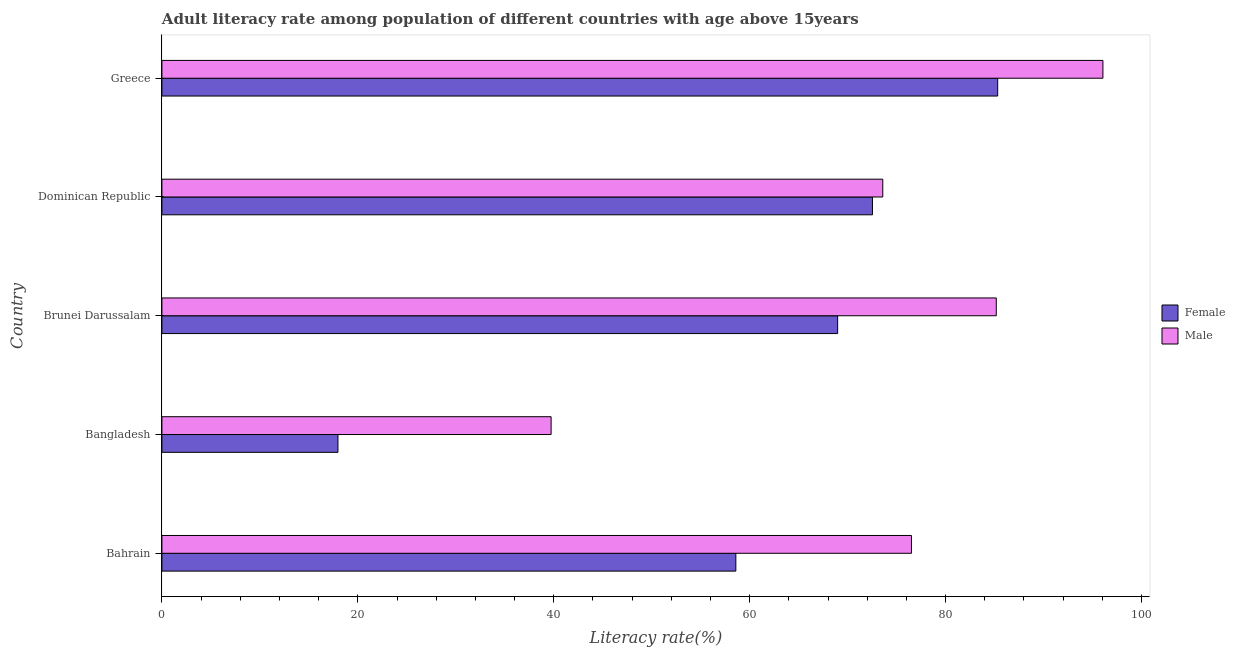How many different coloured bars are there?
Make the answer very short. 2. How many groups of bars are there?
Keep it short and to the point. 5. Are the number of bars per tick equal to the number of legend labels?
Your answer should be compact. Yes. How many bars are there on the 2nd tick from the top?
Offer a very short reply. 2. What is the label of the 5th group of bars from the top?
Offer a terse response. Bahrain. In how many cases, is the number of bars for a given country not equal to the number of legend labels?
Make the answer very short. 0. What is the female adult literacy rate in Dominican Republic?
Make the answer very short. 72.54. Across all countries, what is the maximum male adult literacy rate?
Offer a terse response. 96.06. Across all countries, what is the minimum female adult literacy rate?
Give a very brief answer. 17.97. In which country was the male adult literacy rate maximum?
Your response must be concise. Greece. In which country was the male adult literacy rate minimum?
Your response must be concise. Bangladesh. What is the total female adult literacy rate in the graph?
Keep it short and to the point. 303.4. What is the difference between the male adult literacy rate in Bahrain and that in Dominican Republic?
Keep it short and to the point. 2.93. What is the difference between the male adult literacy rate in Brunei Darussalam and the female adult literacy rate in Greece?
Your response must be concise. -0.14. What is the average female adult literacy rate per country?
Offer a terse response. 60.68. What is the difference between the female adult literacy rate and male adult literacy rate in Bangladesh?
Offer a terse response. -21.76. In how many countries, is the female adult literacy rate greater than 24 %?
Your response must be concise. 4. What is the ratio of the male adult literacy rate in Bahrain to that in Greece?
Keep it short and to the point. 0.8. Is the female adult literacy rate in Brunei Darussalam less than that in Greece?
Make the answer very short. Yes. Is the difference between the female adult literacy rate in Bangladesh and Brunei Darussalam greater than the difference between the male adult literacy rate in Bangladesh and Brunei Darussalam?
Keep it short and to the point. No. What is the difference between the highest and the second highest female adult literacy rate?
Give a very brief answer. 12.78. What is the difference between the highest and the lowest female adult literacy rate?
Your answer should be compact. 67.35. What does the 2nd bar from the top in Dominican Republic represents?
Provide a short and direct response. Female. What does the 1st bar from the bottom in Bahrain represents?
Give a very brief answer. Female. How many bars are there?
Provide a succinct answer. 10. Are all the bars in the graph horizontal?
Provide a short and direct response. Yes. How many countries are there in the graph?
Ensure brevity in your answer.  5. Where does the legend appear in the graph?
Your answer should be compact. Center right. How many legend labels are there?
Ensure brevity in your answer.  2. What is the title of the graph?
Your answer should be compact. Adult literacy rate among population of different countries with age above 15years. Does "Female labourers" appear as one of the legend labels in the graph?
Offer a terse response. No. What is the label or title of the X-axis?
Offer a very short reply. Literacy rate(%). What is the Literacy rate(%) of Female in Bahrain?
Keep it short and to the point. 58.59. What is the Literacy rate(%) of Male in Bahrain?
Offer a very short reply. 76.52. What is the Literacy rate(%) of Female in Bangladesh?
Your response must be concise. 17.97. What is the Literacy rate(%) in Male in Bangladesh?
Your response must be concise. 39.73. What is the Literacy rate(%) of Female in Brunei Darussalam?
Make the answer very short. 68.98. What is the Literacy rate(%) of Male in Brunei Darussalam?
Make the answer very short. 85.18. What is the Literacy rate(%) in Female in Dominican Republic?
Ensure brevity in your answer.  72.54. What is the Literacy rate(%) in Male in Dominican Republic?
Keep it short and to the point. 73.59. What is the Literacy rate(%) of Female in Greece?
Give a very brief answer. 85.32. What is the Literacy rate(%) in Male in Greece?
Provide a short and direct response. 96.06. Across all countries, what is the maximum Literacy rate(%) of Female?
Offer a terse response. 85.32. Across all countries, what is the maximum Literacy rate(%) of Male?
Make the answer very short. 96.06. Across all countries, what is the minimum Literacy rate(%) of Female?
Give a very brief answer. 17.97. Across all countries, what is the minimum Literacy rate(%) in Male?
Provide a short and direct response. 39.73. What is the total Literacy rate(%) in Female in the graph?
Ensure brevity in your answer.  303.4. What is the total Literacy rate(%) of Male in the graph?
Make the answer very short. 371.08. What is the difference between the Literacy rate(%) in Female in Bahrain and that in Bangladesh?
Your answer should be very brief. 40.62. What is the difference between the Literacy rate(%) of Male in Bahrain and that in Bangladesh?
Provide a succinct answer. 36.79. What is the difference between the Literacy rate(%) in Female in Bahrain and that in Brunei Darussalam?
Keep it short and to the point. -10.39. What is the difference between the Literacy rate(%) of Male in Bahrain and that in Brunei Darussalam?
Your answer should be very brief. -8.66. What is the difference between the Literacy rate(%) in Female in Bahrain and that in Dominican Republic?
Provide a succinct answer. -13.95. What is the difference between the Literacy rate(%) in Male in Bahrain and that in Dominican Republic?
Keep it short and to the point. 2.93. What is the difference between the Literacy rate(%) of Female in Bahrain and that in Greece?
Provide a succinct answer. -26.73. What is the difference between the Literacy rate(%) of Male in Bahrain and that in Greece?
Give a very brief answer. -19.55. What is the difference between the Literacy rate(%) of Female in Bangladesh and that in Brunei Darussalam?
Keep it short and to the point. -51.01. What is the difference between the Literacy rate(%) in Male in Bangladesh and that in Brunei Darussalam?
Make the answer very short. -45.45. What is the difference between the Literacy rate(%) in Female in Bangladesh and that in Dominican Republic?
Provide a short and direct response. -54.56. What is the difference between the Literacy rate(%) of Male in Bangladesh and that in Dominican Republic?
Your response must be concise. -33.86. What is the difference between the Literacy rate(%) of Female in Bangladesh and that in Greece?
Offer a very short reply. -67.35. What is the difference between the Literacy rate(%) in Male in Bangladesh and that in Greece?
Provide a succinct answer. -56.33. What is the difference between the Literacy rate(%) in Female in Brunei Darussalam and that in Dominican Republic?
Provide a succinct answer. -3.55. What is the difference between the Literacy rate(%) in Male in Brunei Darussalam and that in Dominican Republic?
Your answer should be compact. 11.59. What is the difference between the Literacy rate(%) in Female in Brunei Darussalam and that in Greece?
Ensure brevity in your answer.  -16.34. What is the difference between the Literacy rate(%) of Male in Brunei Darussalam and that in Greece?
Offer a very short reply. -10.89. What is the difference between the Literacy rate(%) of Female in Dominican Republic and that in Greece?
Offer a terse response. -12.78. What is the difference between the Literacy rate(%) of Male in Dominican Republic and that in Greece?
Ensure brevity in your answer.  -22.47. What is the difference between the Literacy rate(%) of Female in Bahrain and the Literacy rate(%) of Male in Bangladesh?
Provide a succinct answer. 18.86. What is the difference between the Literacy rate(%) of Female in Bahrain and the Literacy rate(%) of Male in Brunei Darussalam?
Offer a very short reply. -26.59. What is the difference between the Literacy rate(%) of Female in Bahrain and the Literacy rate(%) of Male in Dominican Republic?
Your response must be concise. -15. What is the difference between the Literacy rate(%) in Female in Bahrain and the Literacy rate(%) in Male in Greece?
Ensure brevity in your answer.  -37.47. What is the difference between the Literacy rate(%) of Female in Bangladesh and the Literacy rate(%) of Male in Brunei Darussalam?
Provide a short and direct response. -67.21. What is the difference between the Literacy rate(%) of Female in Bangladesh and the Literacy rate(%) of Male in Dominican Republic?
Make the answer very short. -55.62. What is the difference between the Literacy rate(%) of Female in Bangladesh and the Literacy rate(%) of Male in Greece?
Your answer should be compact. -78.09. What is the difference between the Literacy rate(%) of Female in Brunei Darussalam and the Literacy rate(%) of Male in Dominican Republic?
Your answer should be compact. -4.61. What is the difference between the Literacy rate(%) of Female in Brunei Darussalam and the Literacy rate(%) of Male in Greece?
Provide a short and direct response. -27.08. What is the difference between the Literacy rate(%) of Female in Dominican Republic and the Literacy rate(%) of Male in Greece?
Keep it short and to the point. -23.53. What is the average Literacy rate(%) of Female per country?
Provide a succinct answer. 60.68. What is the average Literacy rate(%) in Male per country?
Your response must be concise. 74.22. What is the difference between the Literacy rate(%) of Female and Literacy rate(%) of Male in Bahrain?
Provide a succinct answer. -17.93. What is the difference between the Literacy rate(%) of Female and Literacy rate(%) of Male in Bangladesh?
Ensure brevity in your answer.  -21.76. What is the difference between the Literacy rate(%) in Female and Literacy rate(%) in Male in Brunei Darussalam?
Your response must be concise. -16.2. What is the difference between the Literacy rate(%) in Female and Literacy rate(%) in Male in Dominican Republic?
Provide a short and direct response. -1.05. What is the difference between the Literacy rate(%) of Female and Literacy rate(%) of Male in Greece?
Offer a terse response. -10.74. What is the ratio of the Literacy rate(%) of Female in Bahrain to that in Bangladesh?
Offer a terse response. 3.26. What is the ratio of the Literacy rate(%) in Male in Bahrain to that in Bangladesh?
Ensure brevity in your answer.  1.93. What is the ratio of the Literacy rate(%) in Female in Bahrain to that in Brunei Darussalam?
Your answer should be very brief. 0.85. What is the ratio of the Literacy rate(%) in Male in Bahrain to that in Brunei Darussalam?
Provide a short and direct response. 0.9. What is the ratio of the Literacy rate(%) in Female in Bahrain to that in Dominican Republic?
Give a very brief answer. 0.81. What is the ratio of the Literacy rate(%) of Male in Bahrain to that in Dominican Republic?
Keep it short and to the point. 1.04. What is the ratio of the Literacy rate(%) in Female in Bahrain to that in Greece?
Make the answer very short. 0.69. What is the ratio of the Literacy rate(%) of Male in Bahrain to that in Greece?
Provide a short and direct response. 0.8. What is the ratio of the Literacy rate(%) of Female in Bangladesh to that in Brunei Darussalam?
Provide a succinct answer. 0.26. What is the ratio of the Literacy rate(%) in Male in Bangladesh to that in Brunei Darussalam?
Provide a short and direct response. 0.47. What is the ratio of the Literacy rate(%) in Female in Bangladesh to that in Dominican Republic?
Make the answer very short. 0.25. What is the ratio of the Literacy rate(%) of Male in Bangladesh to that in Dominican Republic?
Your answer should be compact. 0.54. What is the ratio of the Literacy rate(%) in Female in Bangladesh to that in Greece?
Keep it short and to the point. 0.21. What is the ratio of the Literacy rate(%) of Male in Bangladesh to that in Greece?
Provide a short and direct response. 0.41. What is the ratio of the Literacy rate(%) of Female in Brunei Darussalam to that in Dominican Republic?
Make the answer very short. 0.95. What is the ratio of the Literacy rate(%) of Male in Brunei Darussalam to that in Dominican Republic?
Give a very brief answer. 1.16. What is the ratio of the Literacy rate(%) of Female in Brunei Darussalam to that in Greece?
Provide a short and direct response. 0.81. What is the ratio of the Literacy rate(%) in Male in Brunei Darussalam to that in Greece?
Your answer should be compact. 0.89. What is the ratio of the Literacy rate(%) of Female in Dominican Republic to that in Greece?
Offer a very short reply. 0.85. What is the ratio of the Literacy rate(%) in Male in Dominican Republic to that in Greece?
Your answer should be compact. 0.77. What is the difference between the highest and the second highest Literacy rate(%) of Female?
Make the answer very short. 12.78. What is the difference between the highest and the second highest Literacy rate(%) in Male?
Keep it short and to the point. 10.89. What is the difference between the highest and the lowest Literacy rate(%) of Female?
Keep it short and to the point. 67.35. What is the difference between the highest and the lowest Literacy rate(%) of Male?
Your response must be concise. 56.33. 